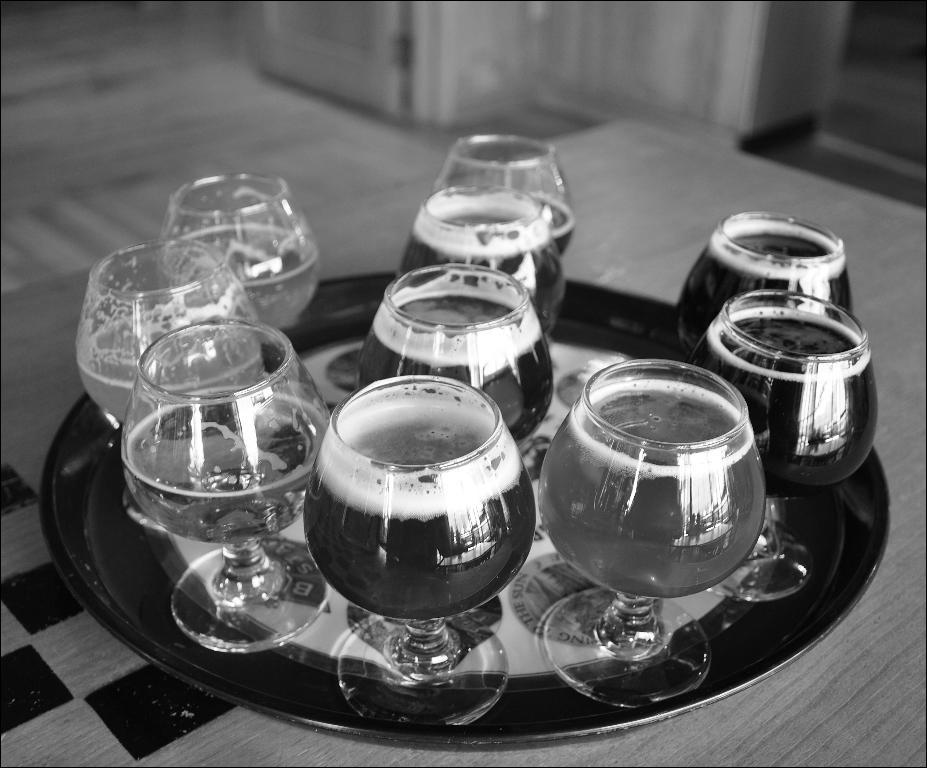What is the color scheme of the image? The image is black and white. What type of containers are holding the beverages in the image? There are glass tumblers holding the beverages in the image. How are the glass tumblers arranged on the plate? The glass tumblers are placed on a plate in the image. Where is the plate located in the image? The plate is placed on a table in the image. How many bikes are visible in the image? There are no bikes present in the image. What type of bun is being served on the plate with the glass tumblers? There is no bun present in the image; the plate only contains glass tumblers with beverages. 